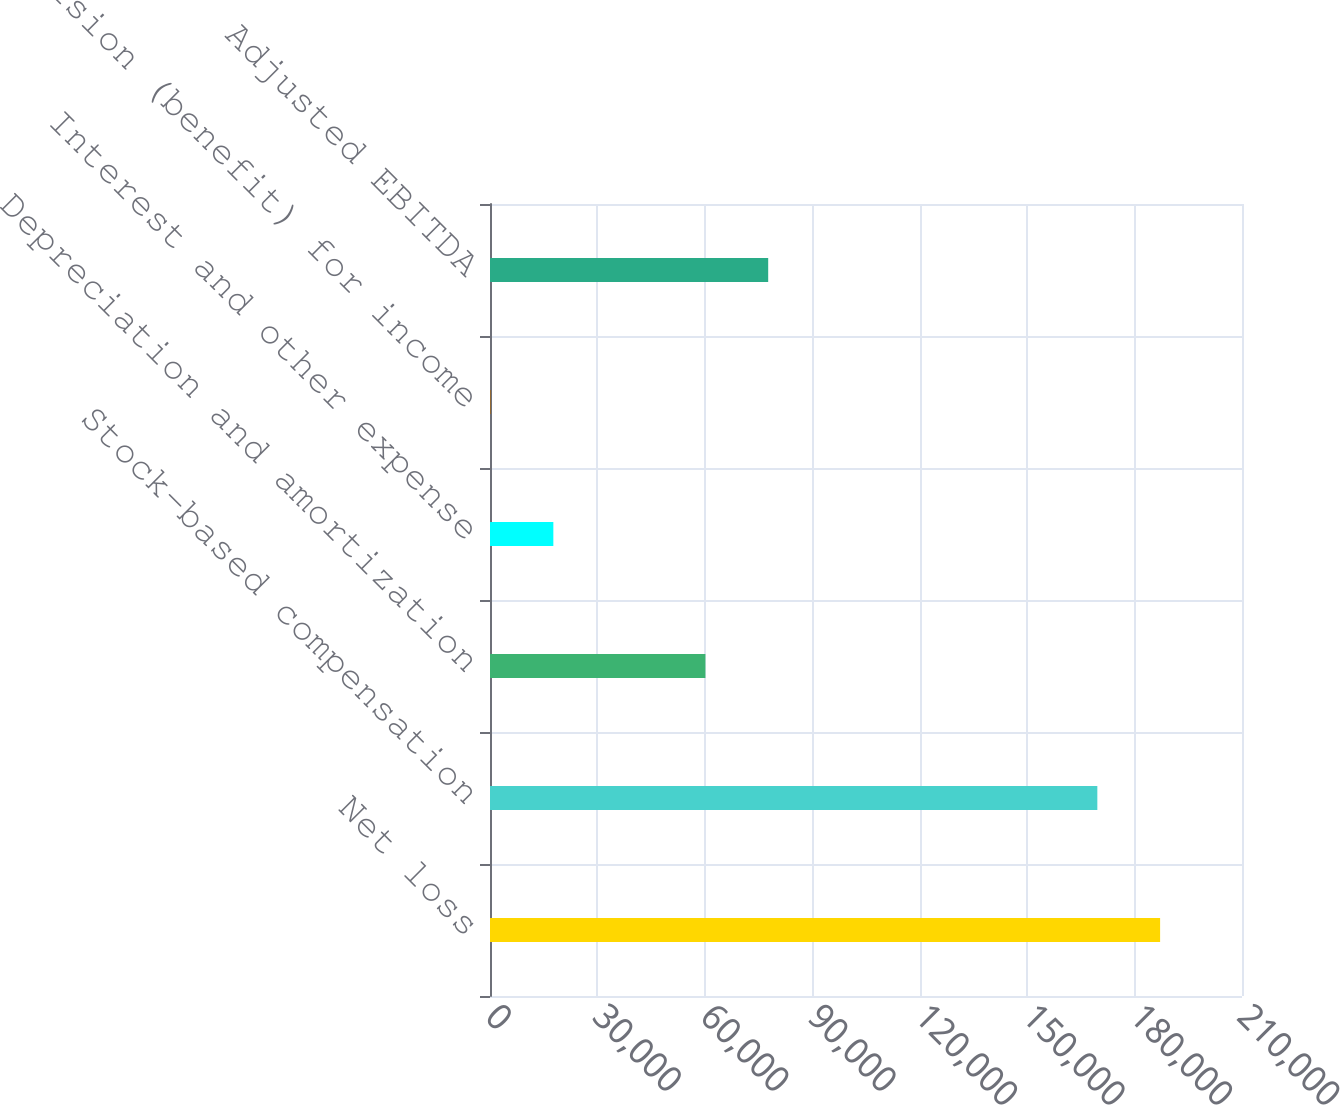Convert chart. <chart><loc_0><loc_0><loc_500><loc_500><bar_chart><fcel>Net loss<fcel>Stock-based compensation<fcel>Depreciation and amortization<fcel>Interest and other expense<fcel>Provision (benefit) for income<fcel>Adjusted EBITDA<nl><fcel>187132<fcel>169602<fcel>60155<fcel>17689.5<fcel>159<fcel>77685.5<nl></chart> 